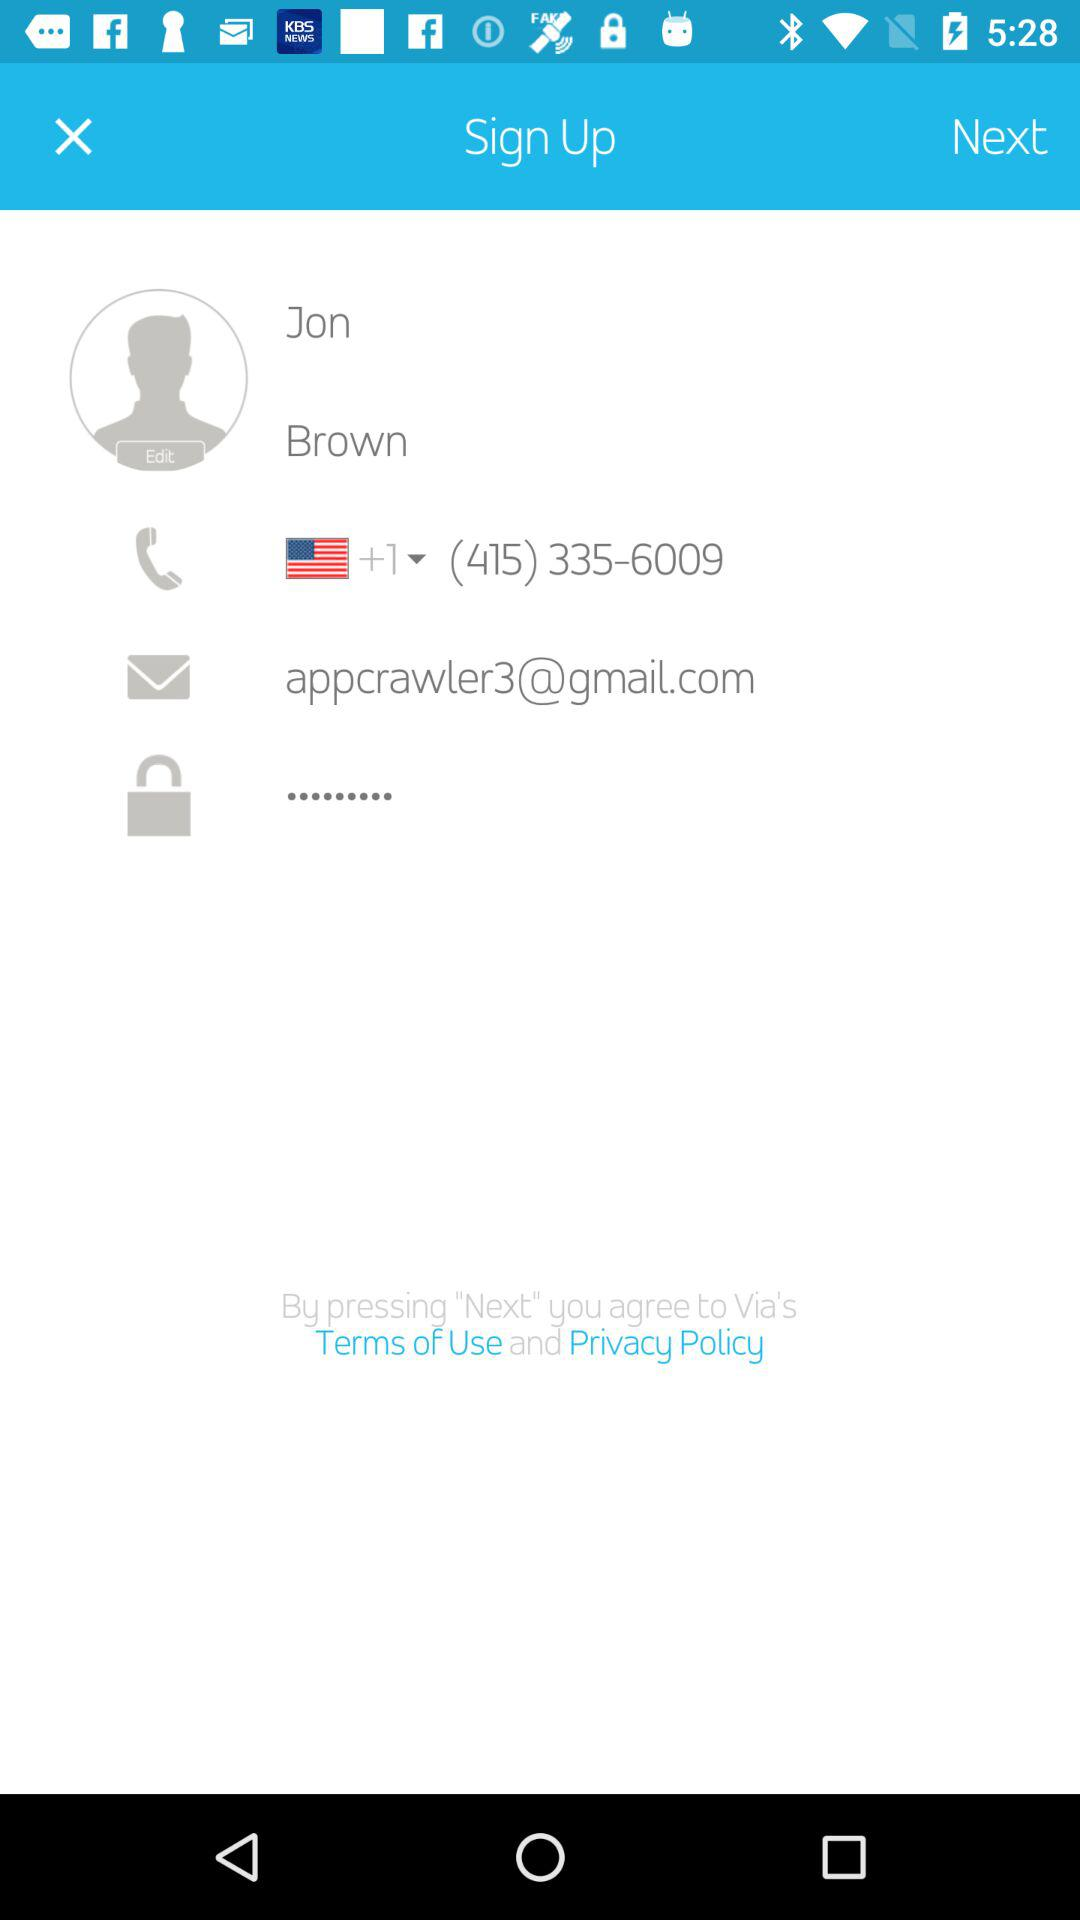What is the name? The name is Jon Brown. 